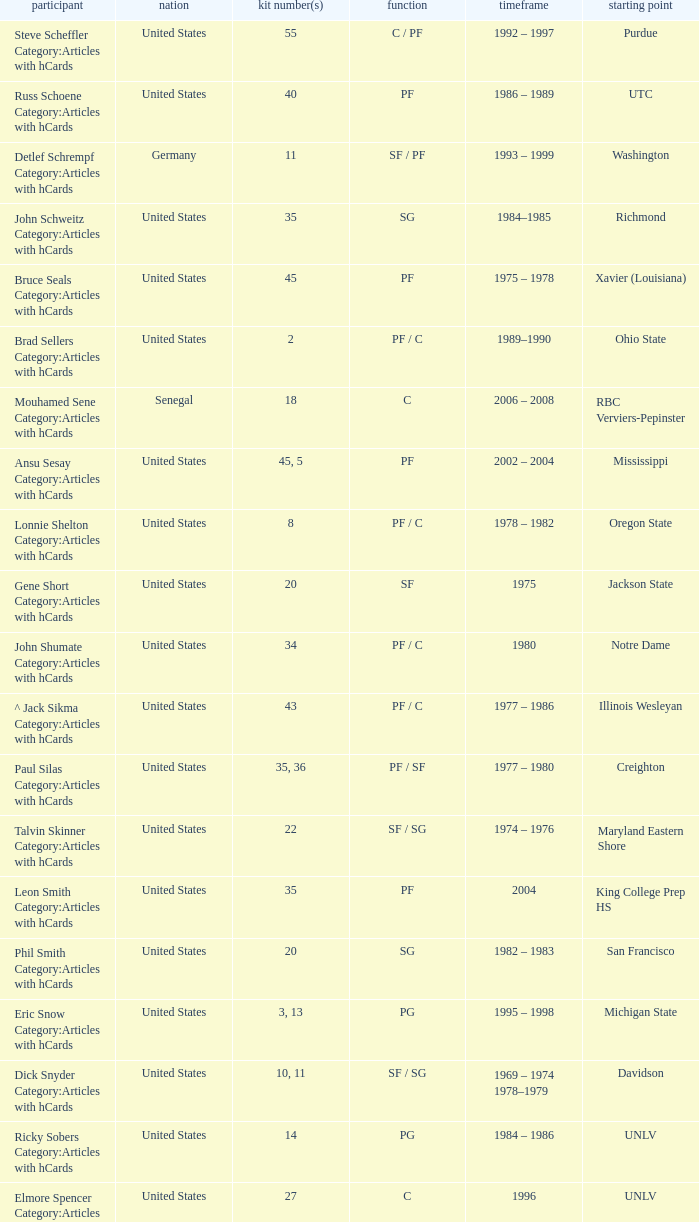What nationality is the player from Oregon State? United States. 